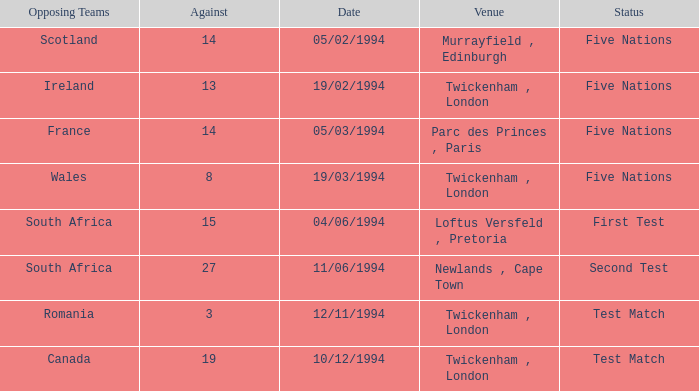Which place has more than 19 against? Newlands , Cape Town. Would you be able to parse every entry in this table? {'header': ['Opposing Teams', 'Against', 'Date', 'Venue', 'Status'], 'rows': [['Scotland', '14', '05/02/1994', 'Murrayfield , Edinburgh', 'Five Nations'], ['Ireland', '13', '19/02/1994', 'Twickenham , London', 'Five Nations'], ['France', '14', '05/03/1994', 'Parc des Princes , Paris', 'Five Nations'], ['Wales', '8', '19/03/1994', 'Twickenham , London', 'Five Nations'], ['South Africa', '15', '04/06/1994', 'Loftus Versfeld , Pretoria', 'First Test'], ['South Africa', '27', '11/06/1994', 'Newlands , Cape Town', 'Second Test'], ['Romania', '3', '12/11/1994', 'Twickenham , London', 'Test Match'], ['Canada', '19', '10/12/1994', 'Twickenham , London', 'Test Match']]} 